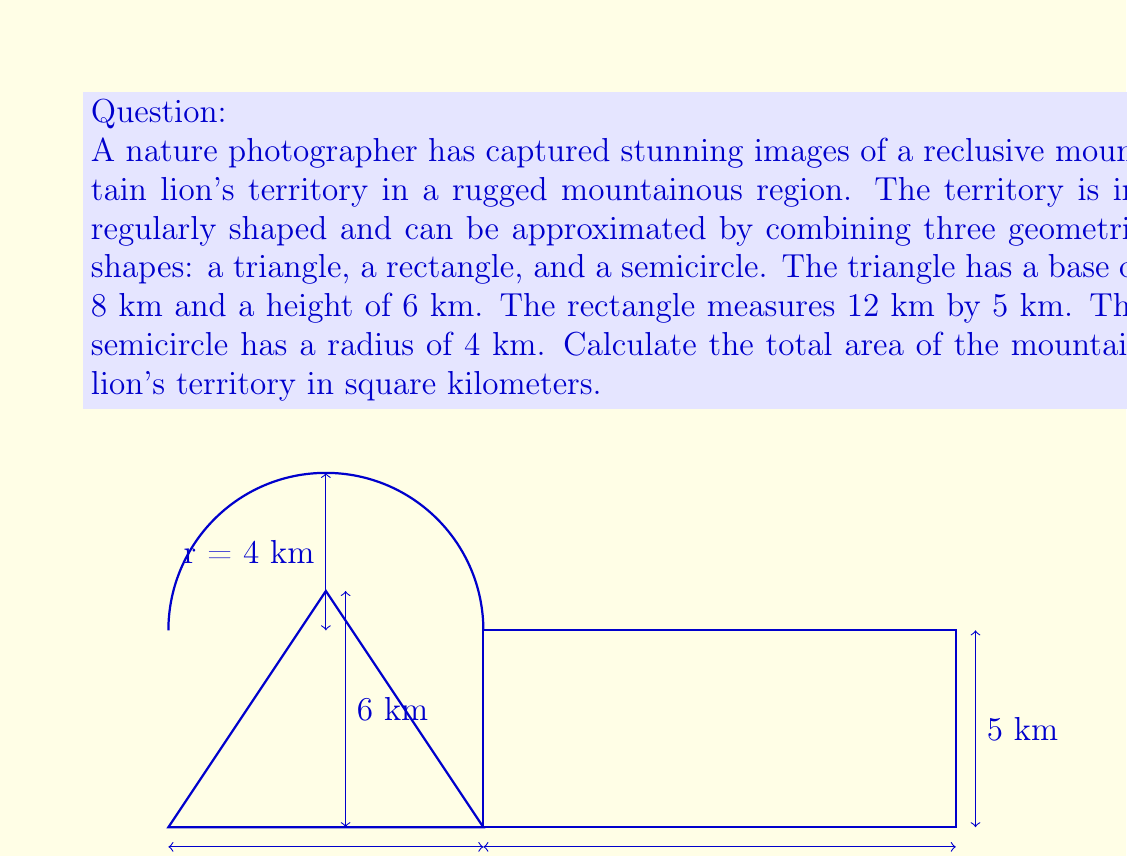What is the answer to this math problem? To calculate the total area of the mountain lion's territory, we need to sum the areas of the three geometric shapes:

1. Area of the triangle:
   $$A_t = \frac{1}{2} \times base \times height = \frac{1}{2} \times 8 \times 6 = 24 \text{ km}^2$$

2. Area of the rectangle:
   $$A_r = length \times width = 12 \times 5 = 60 \text{ km}^2$$

3. Area of the semicircle:
   $$A_s = \frac{1}{2} \times \pi r^2 = \frac{1}{2} \times \pi \times 4^2 = 8\pi \text{ km}^2$$

Now, we sum these areas to get the total area:

$$\begin{align*}
A_{total} &= A_t + A_r + A_s \\
&= 24 + 60 + 8\pi \\
&= 84 + 8\pi \text{ km}^2
\end{align*}$$

To get a numerical value, we can use $\pi \approx 3.14159$:

$$\begin{align*}
A_{total} &\approx 84 + 8(3.14159) \\
&\approx 84 + 25.13272 \\
&\approx 109.13272 \text{ km}^2
\end{align*}$$
Answer: The total area of the mountain lion's territory is $84 + 8\pi \approx 109.13 \text{ km}^2$. 